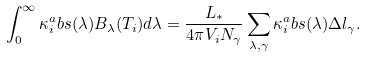Convert formula to latex. <formula><loc_0><loc_0><loc_500><loc_500>\int _ { 0 } ^ { \infty } \kappa _ { i } ^ { a } b s ( \lambda ) B _ { \lambda } ( T _ { i } ) d \lambda = \frac { L _ { * } } { 4 \pi V _ { i } N _ { \gamma } } \sum _ { \lambda , \gamma } \kappa _ { i } ^ { a } b s ( \lambda ) \Delta l _ { \gamma } .</formula> 